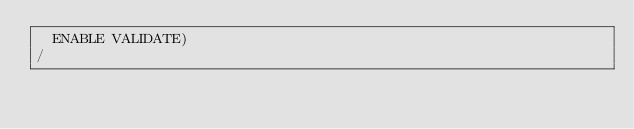Convert code to text. <code><loc_0><loc_0><loc_500><loc_500><_SQL_>  ENABLE VALIDATE)
/
</code> 